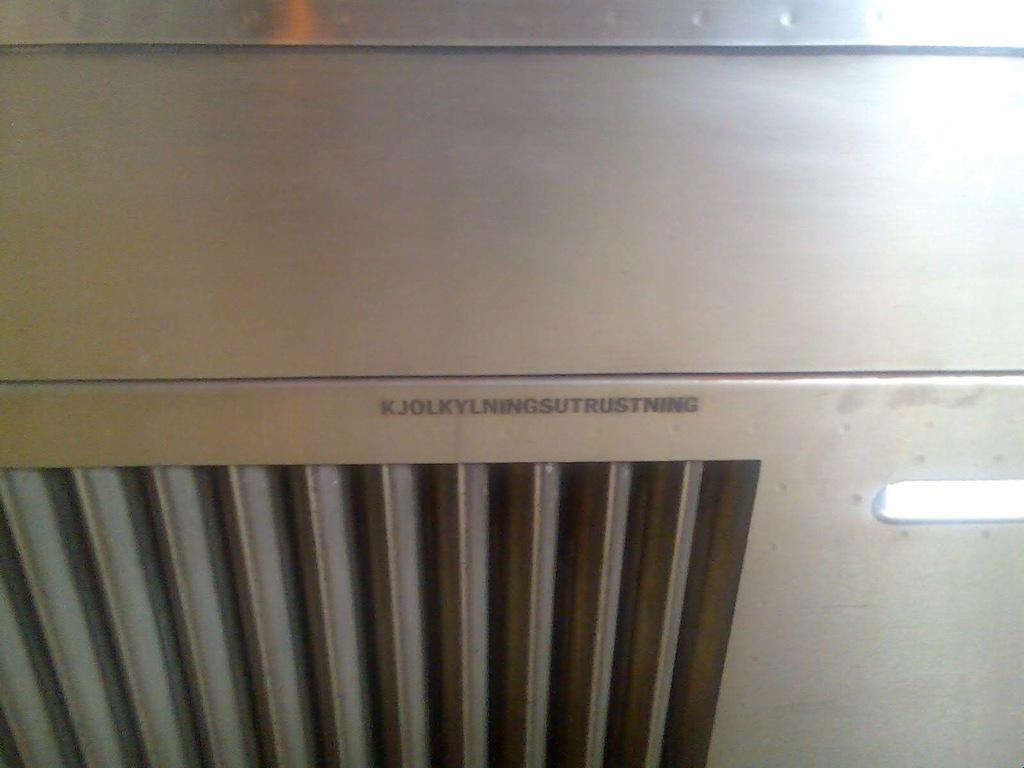<image>
Provide a brief description of the given image. A piece of silver equipment with air vents that has the word trust in a long series of letters. 